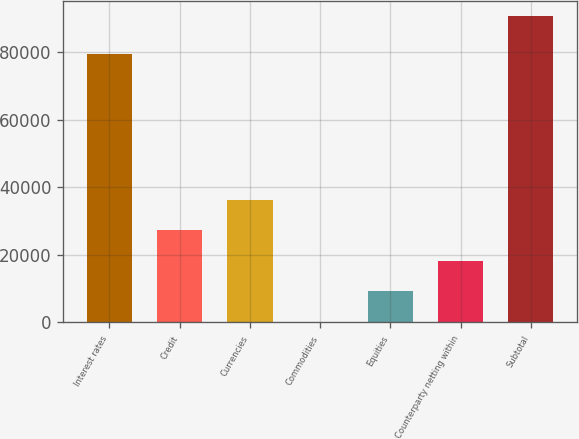<chart> <loc_0><loc_0><loc_500><loc_500><bar_chart><fcel>Interest rates<fcel>Credit<fcel>Currencies<fcel>Commodities<fcel>Equities<fcel>Counterparty netting within<fcel>Subtotal<nl><fcel>79507<fcel>27290.3<fcel>36327.4<fcel>179<fcel>9216.1<fcel>18253.2<fcel>90550<nl></chart> 